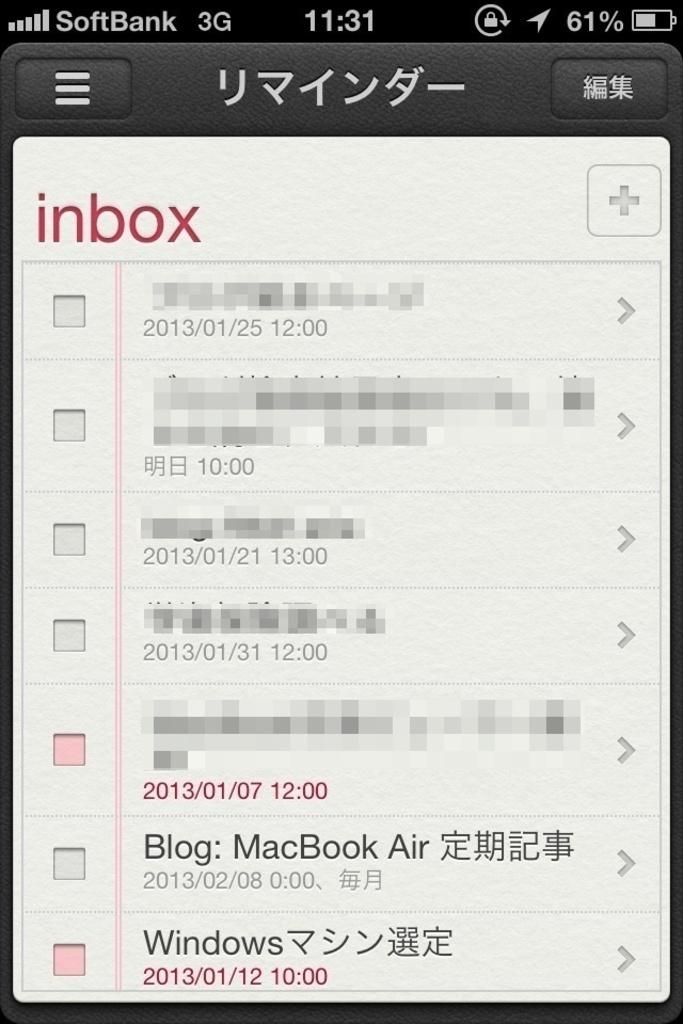What type of screen is shown in the image? The image shows a mobile screen. What can be seen on the mobile screen? There is text, dates, numbers, and symbols visible on the mobile screen. Can you see any veins on the mobile screen in the image? There are no veins visible on the mobile screen in the image, as veins are not a feature of mobile screens. 